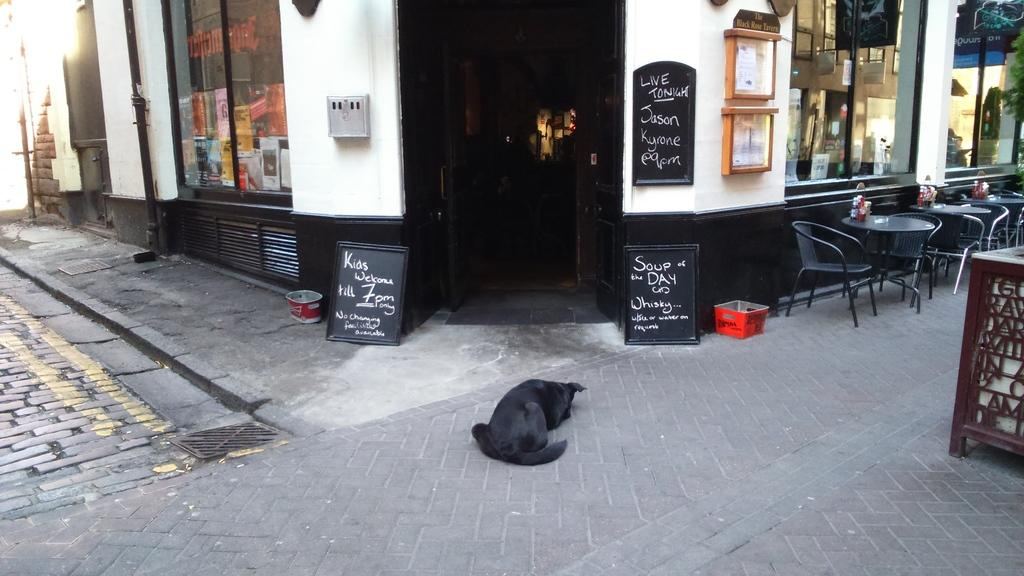What type of animal is in the image? There is a black dog in the image. What is the dog doing in the image? The dog is laying on the street. Where is the dog located in the image? The dog is on the street. What can be seen in the background of the image? There is a building in the background of the image. What is in front of the building? The building has chairs and tables in front of it. What type of establishment might the building be? The building appears to be a hotel. How many bushes are surrounding the dog in the image? There are no bushes visible in the image; it only features a black dog laying on the street and a building in the background. 